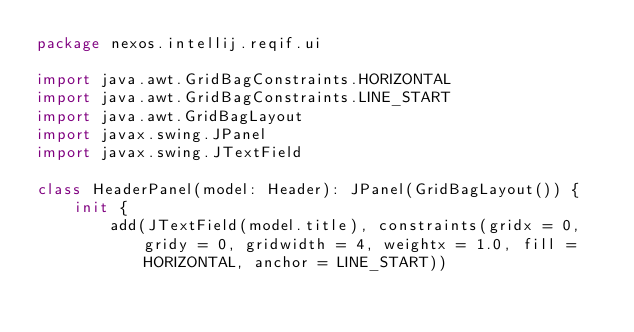<code> <loc_0><loc_0><loc_500><loc_500><_Kotlin_>package nexos.intellij.reqif.ui

import java.awt.GridBagConstraints.HORIZONTAL
import java.awt.GridBagConstraints.LINE_START
import java.awt.GridBagLayout
import javax.swing.JPanel
import javax.swing.JTextField

class HeaderPanel(model: Header): JPanel(GridBagLayout()) {
    init {
        add(JTextField(model.title), constraints(gridx = 0, gridy = 0, gridwidth = 4, weightx = 1.0, fill = HORIZONTAL, anchor = LINE_START))</code> 